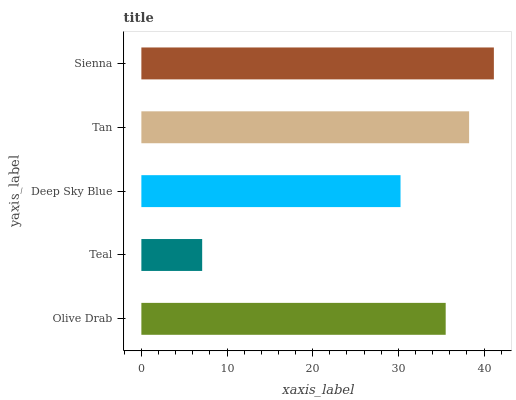Is Teal the minimum?
Answer yes or no. Yes. Is Sienna the maximum?
Answer yes or no. Yes. Is Deep Sky Blue the minimum?
Answer yes or no. No. Is Deep Sky Blue the maximum?
Answer yes or no. No. Is Deep Sky Blue greater than Teal?
Answer yes or no. Yes. Is Teal less than Deep Sky Blue?
Answer yes or no. Yes. Is Teal greater than Deep Sky Blue?
Answer yes or no. No. Is Deep Sky Blue less than Teal?
Answer yes or no. No. Is Olive Drab the high median?
Answer yes or no. Yes. Is Olive Drab the low median?
Answer yes or no. Yes. Is Teal the high median?
Answer yes or no. No. Is Tan the low median?
Answer yes or no. No. 